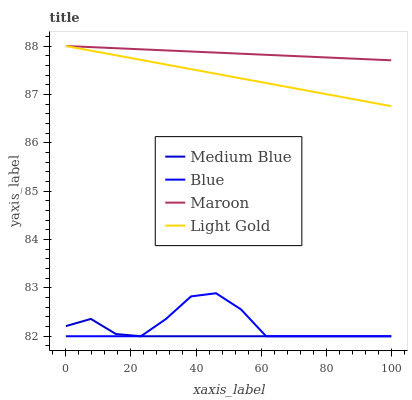Does Medium Blue have the minimum area under the curve?
Answer yes or no. Yes. Does Maroon have the maximum area under the curve?
Answer yes or no. Yes. Does Light Gold have the minimum area under the curve?
Answer yes or no. No. Does Light Gold have the maximum area under the curve?
Answer yes or no. No. Is Maroon the smoothest?
Answer yes or no. Yes. Is Blue the roughest?
Answer yes or no. Yes. Is Light Gold the smoothest?
Answer yes or no. No. Is Light Gold the roughest?
Answer yes or no. No. Does Blue have the lowest value?
Answer yes or no. Yes. Does Light Gold have the lowest value?
Answer yes or no. No. Does Maroon have the highest value?
Answer yes or no. Yes. Does Medium Blue have the highest value?
Answer yes or no. No. Is Medium Blue less than Maroon?
Answer yes or no. Yes. Is Maroon greater than Medium Blue?
Answer yes or no. Yes. Does Maroon intersect Light Gold?
Answer yes or no. Yes. Is Maroon less than Light Gold?
Answer yes or no. No. Is Maroon greater than Light Gold?
Answer yes or no. No. Does Medium Blue intersect Maroon?
Answer yes or no. No. 